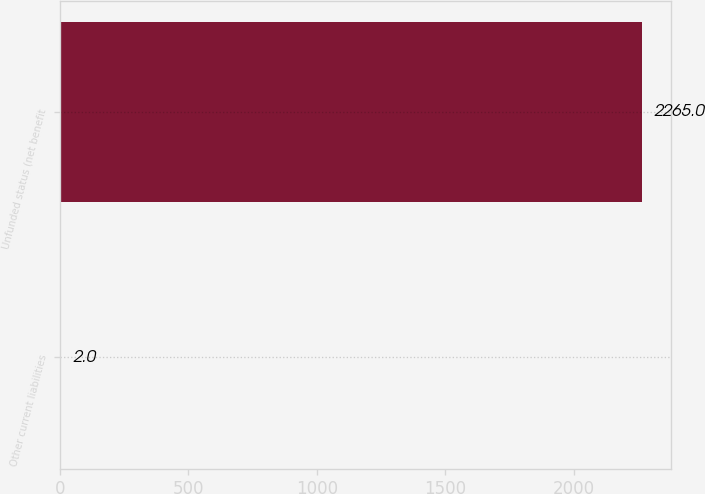Convert chart. <chart><loc_0><loc_0><loc_500><loc_500><bar_chart><fcel>Other current liabilities<fcel>Unfunded status (net benefit<nl><fcel>2<fcel>2265<nl></chart> 